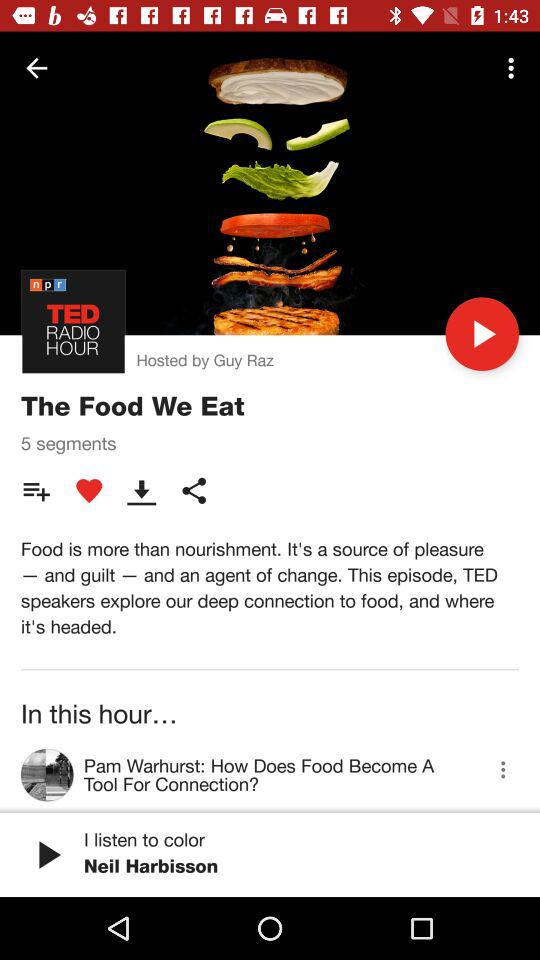What is the name of the episode? The name of the episode is "The Food We Eat". 